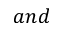<formula> <loc_0><loc_0><loc_500><loc_500>a n d</formula> 